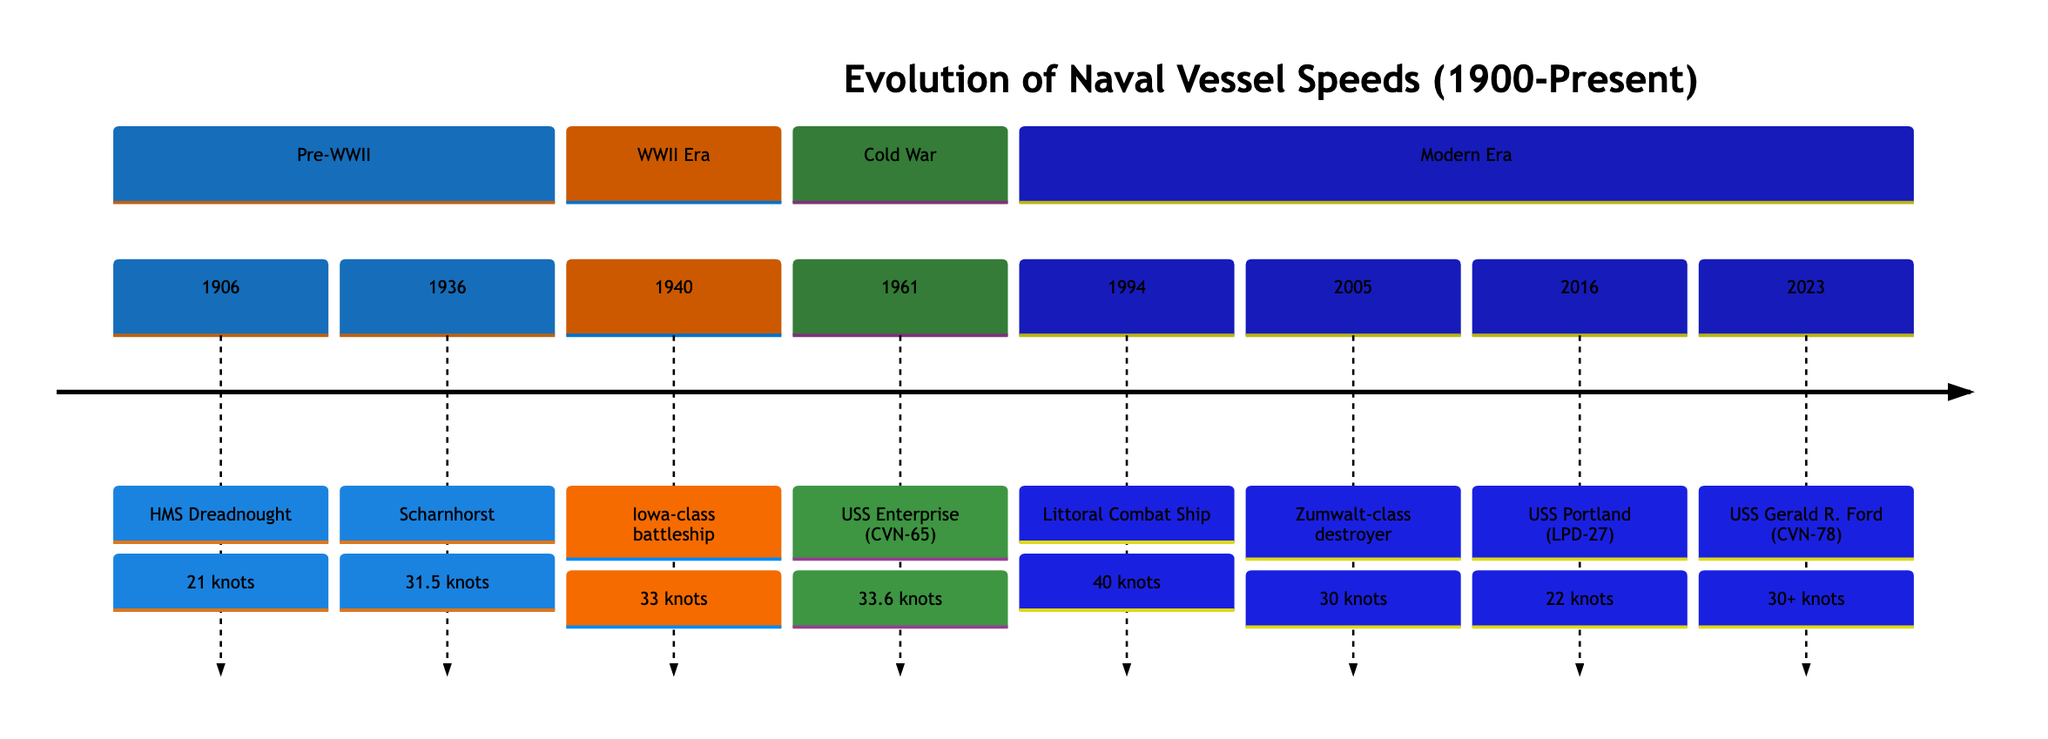What year did HMS Dreadnought achieve its speed? HMS Dreadnought is listed in the timeline as having a speed of 21 knots and is dated 1906. Therefore, its speed achievement year is found directly alongside its entry.
Answer: 1906 What is the speed of the Littoral Combat Ship? The Littoral Combat Ship is indicated in the timeline as having a speed of 40 knots, which can be read directly from its entry.
Answer: 40 knots Which vessel achieved the highest speed before 2000? By examining the entries before the year 2000, the Littoral Combat Ship at 40 knots stands out as the one with the highest speed, as it's the only vessel listed that exceeds the speed of all others prior to that year.
Answer: Littoral Combat Ship What is the speed of the USS Portland? The USS Portland is recorded in the timeline as having a speed of 22 knots, explicitly stated in its entry.
Answer: 22 knots Which vessel was the fastest during WWII? The only vessel from the WWII section is the Iowa-class battleship, which has a speed of 33 knots. Hence, it is also the fastest recorded during that era according to this timeline.
Answer: Iowa-class battleship How many vessels had a speed equal to or greater than 30 knots and were built after 2000? There are four vessels listed after 2000 meeting this criterion: the Littoral Combat Ship (40 knots), the Zumwalt-class destroyer (30 knots), the USS Gerald R. Ford (30+ knots), and any interpretation of "30 knots" as equal to.
Answer: 4 Who was the first nuclear-powered aircraft carrier, and what was its speed? The timeline indicates that the USS Enterprise (CVN-65) was the first nuclear-powered aircraft carrier with a speed of 33.6 knots, which is detailed in its section appropriately.
Answer: USS Enterprise (CVN-65), 33.6 knots How many vessels were recorded with speeds under 30 knots? Analyzing the timeline reveals that there are three vessels with speeds below 30 knots: HMS Dreadnought (21 knots), USS Portland (22 knots), and Zumwalt-class destroyer (30 knots, but not under). Therefore, only two are clearly under 30 knots.
Answer: 2 What speed did the Scharnhorst achieve? The Scharnhorst, recorded in 1936, is shown to have a speed of 31.5 knots directly from its entry in the timeline information.
Answer: 31.5 knots 